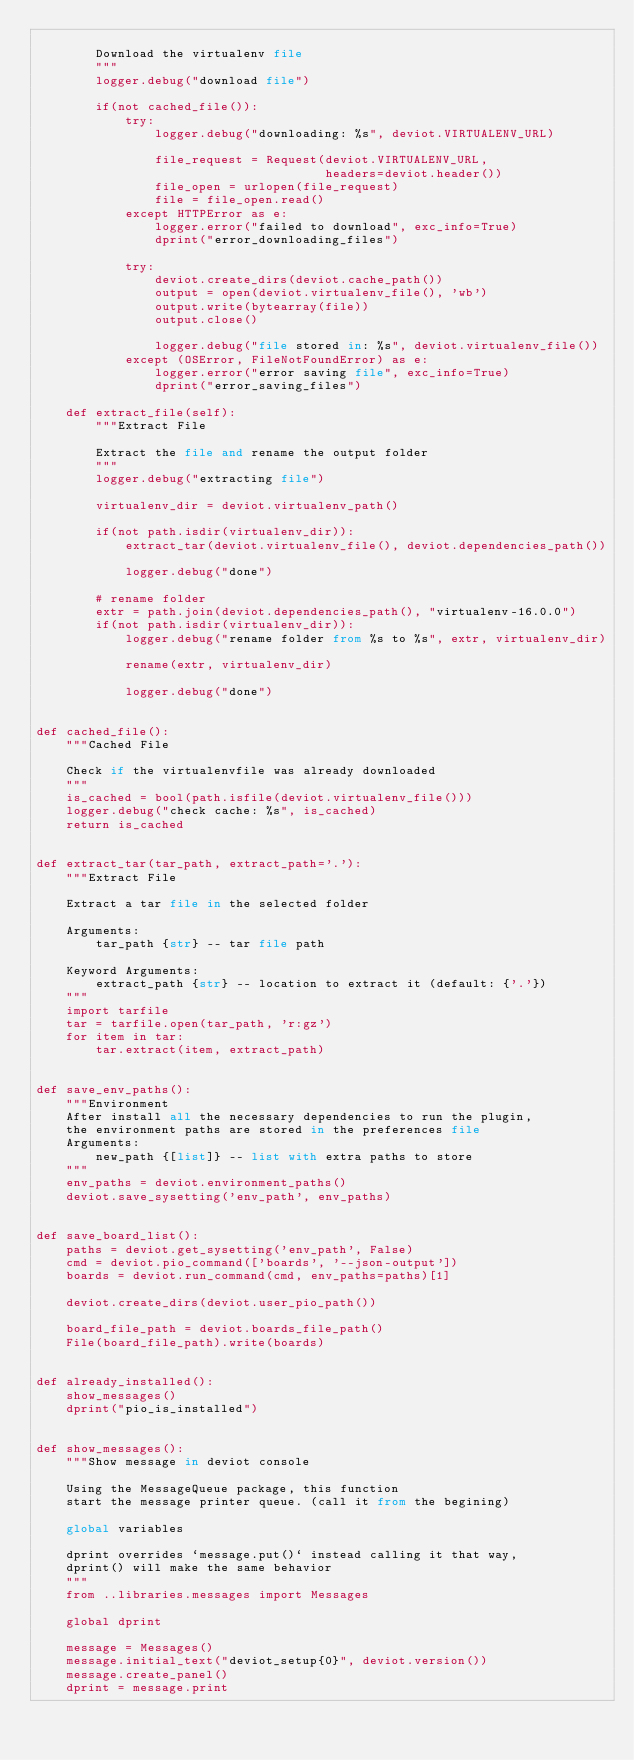<code> <loc_0><loc_0><loc_500><loc_500><_Python_>
        Download the virtualenv file
        """
        logger.debug("download file")

        if(not cached_file()):
            try:
                logger.debug("downloading: %s", deviot.VIRTUALENV_URL)

                file_request = Request(deviot.VIRTUALENV_URL,
                                       headers=deviot.header())
                file_open = urlopen(file_request)
                file = file_open.read()
            except HTTPError as e:
                logger.error("failed to download", exc_info=True)
                dprint("error_downloading_files")

            try:
                deviot.create_dirs(deviot.cache_path())
                output = open(deviot.virtualenv_file(), 'wb')
                output.write(bytearray(file))
                output.close()

                logger.debug("file stored in: %s", deviot.virtualenv_file())
            except (OSError, FileNotFoundError) as e:
                logger.error("error saving file", exc_info=True)
                dprint("error_saving_files")

    def extract_file(self):
        """Extract File

        Extract the file and rename the output folder
        """
        logger.debug("extracting file")

        virtualenv_dir = deviot.virtualenv_path()

        if(not path.isdir(virtualenv_dir)):
            extract_tar(deviot.virtualenv_file(), deviot.dependencies_path())

            logger.debug("done")

        # rename folder
        extr = path.join(deviot.dependencies_path(), "virtualenv-16.0.0")
        if(not path.isdir(virtualenv_dir)):
            logger.debug("rename folder from %s to %s", extr, virtualenv_dir)

            rename(extr, virtualenv_dir)

            logger.debug("done")


def cached_file():
    """Cached File

    Check if the virtualenvfile was already downloaded
    """
    is_cached = bool(path.isfile(deviot.virtualenv_file()))
    logger.debug("check cache: %s", is_cached)
    return is_cached


def extract_tar(tar_path, extract_path='.'):
    """Extract File

    Extract a tar file in the selected folder

    Arguments:
        tar_path {str} -- tar file path

    Keyword Arguments:
        extract_path {str} -- location to extract it (default: {'.'})
    """
    import tarfile
    tar = tarfile.open(tar_path, 'r:gz')
    for item in tar:
        tar.extract(item, extract_path)


def save_env_paths():
    """Environment
    After install all the necessary dependencies to run the plugin,
    the environment paths are stored in the preferences file
    Arguments:
        new_path {[list]} -- list with extra paths to store
    """
    env_paths = deviot.environment_paths()
    deviot.save_sysetting('env_path', env_paths)


def save_board_list():
    paths = deviot.get_sysetting('env_path', False)
    cmd = deviot.pio_command(['boards', '--json-output'])
    boards = deviot.run_command(cmd, env_paths=paths)[1]

    deviot.create_dirs(deviot.user_pio_path())

    board_file_path = deviot.boards_file_path()
    File(board_file_path).write(boards)


def already_installed():
    show_messages()
    dprint("pio_is_installed")


def show_messages():
    """Show message in deviot console

    Using the MessageQueue package, this function
    start the message printer queue. (call it from the begining)

    global variables

    dprint overrides `message.put()` instead calling it that way,
    dprint() will make the same behavior
    """
    from ..libraries.messages import Messages

    global dprint

    message = Messages()
    message.initial_text("deviot_setup{0}", deviot.version())
    message.create_panel()
    dprint = message.print
</code> 